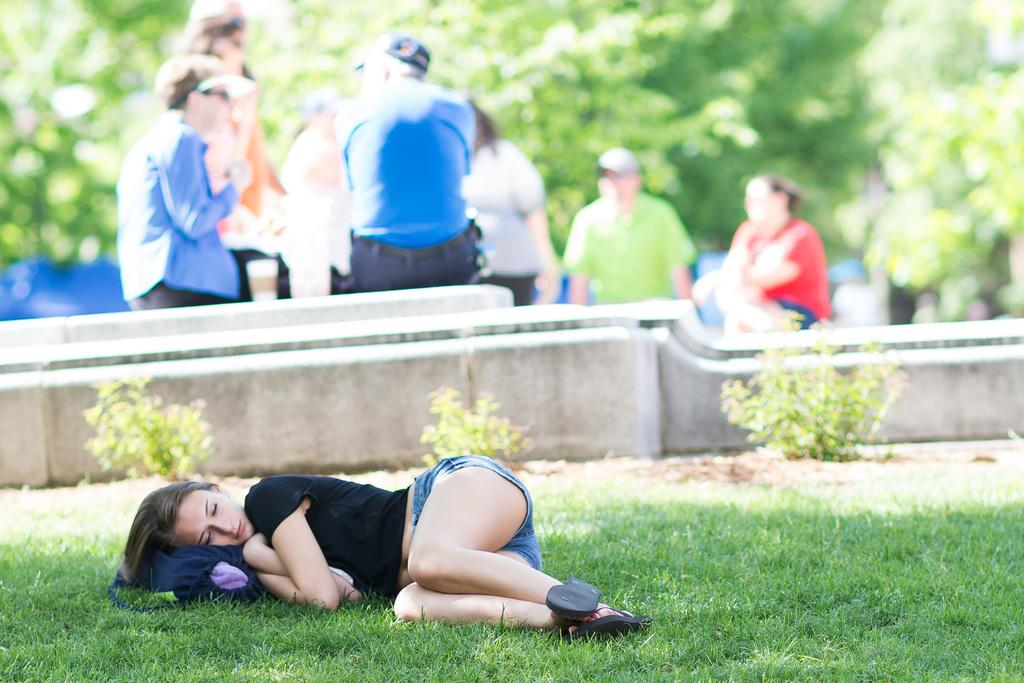What is the main subject in the foreground of the image? There is a lady sleeping in the foreground of the image. Where is the lady sleeping? The lady is sleeping on the grass. What can be seen in the background of the image? There are people and trees in the background of the image. What is present in the center of the image? There are plants in the center of the image. What type of mark does the lady have on her forehead in the image? There is no mark visible on the lady's forehead in the image. What does the lady love in the image? There is no indication of the lady's emotions or preferences in the image. 